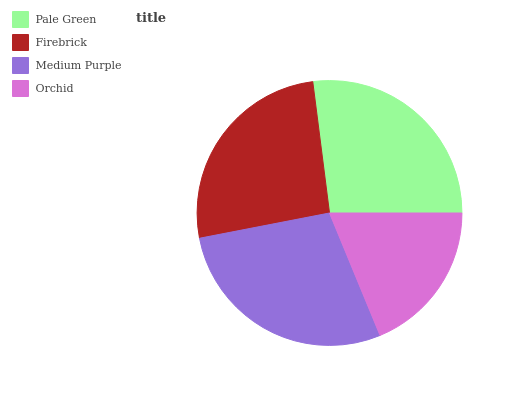Is Orchid the minimum?
Answer yes or no. Yes. Is Medium Purple the maximum?
Answer yes or no. Yes. Is Firebrick the minimum?
Answer yes or no. No. Is Firebrick the maximum?
Answer yes or no. No. Is Pale Green greater than Firebrick?
Answer yes or no. Yes. Is Firebrick less than Pale Green?
Answer yes or no. Yes. Is Firebrick greater than Pale Green?
Answer yes or no. No. Is Pale Green less than Firebrick?
Answer yes or no. No. Is Pale Green the high median?
Answer yes or no. Yes. Is Firebrick the low median?
Answer yes or no. Yes. Is Firebrick the high median?
Answer yes or no. No. Is Pale Green the low median?
Answer yes or no. No. 